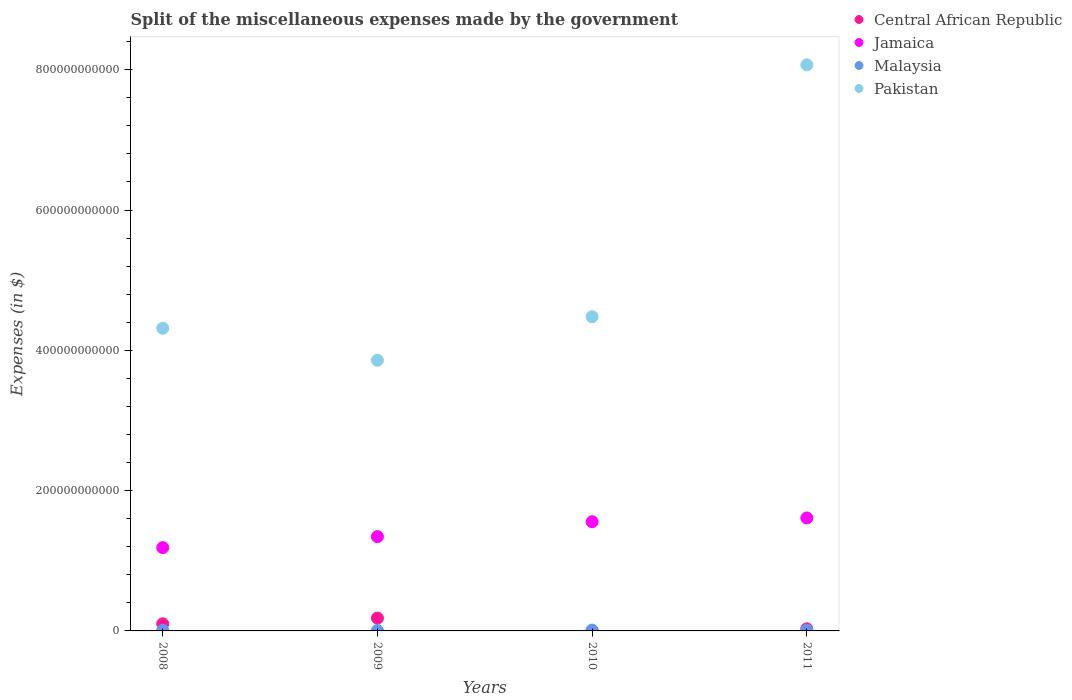What is the miscellaneous expenses made by the government in Pakistan in 2011?
Give a very brief answer. 8.07e+11. Across all years, what is the maximum miscellaneous expenses made by the government in Jamaica?
Provide a succinct answer. 1.61e+11. Across all years, what is the minimum miscellaneous expenses made by the government in Pakistan?
Keep it short and to the point. 3.86e+11. In which year was the miscellaneous expenses made by the government in Malaysia maximum?
Make the answer very short. 2010. What is the total miscellaneous expenses made by the government in Malaysia in the graph?
Provide a succinct answer. 3.83e+09. What is the difference between the miscellaneous expenses made by the government in Malaysia in 2008 and that in 2011?
Ensure brevity in your answer.  -2.89e+08. What is the difference between the miscellaneous expenses made by the government in Pakistan in 2011 and the miscellaneous expenses made by the government in Central African Republic in 2009?
Your response must be concise. 7.89e+11. What is the average miscellaneous expenses made by the government in Central African Republic per year?
Make the answer very short. 7.96e+09. In the year 2011, what is the difference between the miscellaneous expenses made by the government in Central African Republic and miscellaneous expenses made by the government in Jamaica?
Ensure brevity in your answer.  -1.58e+11. In how many years, is the miscellaneous expenses made by the government in Pakistan greater than 760000000000 $?
Provide a succinct answer. 1. What is the ratio of the miscellaneous expenses made by the government in Jamaica in 2008 to that in 2011?
Your answer should be compact. 0.74. Is the miscellaneous expenses made by the government in Jamaica in 2010 less than that in 2011?
Ensure brevity in your answer.  Yes. Is the difference between the miscellaneous expenses made by the government in Central African Republic in 2008 and 2011 greater than the difference between the miscellaneous expenses made by the government in Jamaica in 2008 and 2011?
Offer a terse response. Yes. What is the difference between the highest and the second highest miscellaneous expenses made by the government in Jamaica?
Your answer should be very brief. 5.40e+09. What is the difference between the highest and the lowest miscellaneous expenses made by the government in Malaysia?
Provide a succinct answer. 4.70e+08. Is the sum of the miscellaneous expenses made by the government in Malaysia in 2008 and 2011 greater than the maximum miscellaneous expenses made by the government in Central African Republic across all years?
Your answer should be compact. No. Is it the case that in every year, the sum of the miscellaneous expenses made by the government in Jamaica and miscellaneous expenses made by the government in Pakistan  is greater than the miscellaneous expenses made by the government in Malaysia?
Provide a succinct answer. Yes. Is the miscellaneous expenses made by the government in Central African Republic strictly less than the miscellaneous expenses made by the government in Pakistan over the years?
Offer a very short reply. Yes. How many dotlines are there?
Keep it short and to the point. 4. How many years are there in the graph?
Provide a short and direct response. 4. What is the difference between two consecutive major ticks on the Y-axis?
Your response must be concise. 2.00e+11. Does the graph contain any zero values?
Your answer should be compact. No. Does the graph contain grids?
Give a very brief answer. No. Where does the legend appear in the graph?
Offer a very short reply. Top right. What is the title of the graph?
Provide a short and direct response. Split of the miscellaneous expenses made by the government. What is the label or title of the X-axis?
Keep it short and to the point. Years. What is the label or title of the Y-axis?
Give a very brief answer. Expenses (in $). What is the Expenses (in $) of Central African Republic in 2008?
Provide a short and direct response. 1.01e+1. What is the Expenses (in $) in Jamaica in 2008?
Make the answer very short. 1.19e+11. What is the Expenses (in $) in Malaysia in 2008?
Offer a very short reply. 8.49e+08. What is the Expenses (in $) in Pakistan in 2008?
Offer a terse response. 4.31e+11. What is the Expenses (in $) of Central African Republic in 2009?
Your answer should be very brief. 1.83e+1. What is the Expenses (in $) in Jamaica in 2009?
Your answer should be very brief. 1.34e+11. What is the Expenses (in $) in Malaysia in 2009?
Your response must be concise. 6.85e+08. What is the Expenses (in $) in Pakistan in 2009?
Your answer should be compact. 3.86e+11. What is the Expenses (in $) in Central African Republic in 2010?
Provide a short and direct response. 4.00e+08. What is the Expenses (in $) of Jamaica in 2010?
Offer a very short reply. 1.56e+11. What is the Expenses (in $) in Malaysia in 2010?
Offer a terse response. 1.15e+09. What is the Expenses (in $) in Pakistan in 2010?
Provide a short and direct response. 4.48e+11. What is the Expenses (in $) in Central African Republic in 2011?
Your answer should be compact. 3.00e+09. What is the Expenses (in $) in Jamaica in 2011?
Your answer should be very brief. 1.61e+11. What is the Expenses (in $) in Malaysia in 2011?
Your response must be concise. 1.14e+09. What is the Expenses (in $) of Pakistan in 2011?
Your answer should be very brief. 8.07e+11. Across all years, what is the maximum Expenses (in $) in Central African Republic?
Your answer should be very brief. 1.83e+1. Across all years, what is the maximum Expenses (in $) of Jamaica?
Provide a short and direct response. 1.61e+11. Across all years, what is the maximum Expenses (in $) of Malaysia?
Provide a short and direct response. 1.15e+09. Across all years, what is the maximum Expenses (in $) of Pakistan?
Provide a short and direct response. 8.07e+11. Across all years, what is the minimum Expenses (in $) of Central African Republic?
Provide a succinct answer. 4.00e+08. Across all years, what is the minimum Expenses (in $) in Jamaica?
Your answer should be very brief. 1.19e+11. Across all years, what is the minimum Expenses (in $) of Malaysia?
Your answer should be compact. 6.85e+08. Across all years, what is the minimum Expenses (in $) of Pakistan?
Give a very brief answer. 3.86e+11. What is the total Expenses (in $) of Central African Republic in the graph?
Your response must be concise. 3.18e+1. What is the total Expenses (in $) in Jamaica in the graph?
Offer a very short reply. 5.70e+11. What is the total Expenses (in $) of Malaysia in the graph?
Offer a terse response. 3.83e+09. What is the total Expenses (in $) of Pakistan in the graph?
Ensure brevity in your answer.  2.07e+12. What is the difference between the Expenses (in $) of Central African Republic in 2008 and that in 2009?
Give a very brief answer. -8.19e+09. What is the difference between the Expenses (in $) in Jamaica in 2008 and that in 2009?
Make the answer very short. -1.57e+1. What is the difference between the Expenses (in $) of Malaysia in 2008 and that in 2009?
Make the answer very short. 1.64e+08. What is the difference between the Expenses (in $) of Pakistan in 2008 and that in 2009?
Your answer should be compact. 4.56e+1. What is the difference between the Expenses (in $) of Central African Republic in 2008 and that in 2010?
Your answer should be compact. 9.72e+09. What is the difference between the Expenses (in $) of Jamaica in 2008 and that in 2010?
Your answer should be compact. -3.69e+1. What is the difference between the Expenses (in $) in Malaysia in 2008 and that in 2010?
Give a very brief answer. -3.06e+08. What is the difference between the Expenses (in $) in Pakistan in 2008 and that in 2010?
Offer a very short reply. -1.65e+1. What is the difference between the Expenses (in $) in Central African Republic in 2008 and that in 2011?
Your answer should be compact. 7.12e+09. What is the difference between the Expenses (in $) of Jamaica in 2008 and that in 2011?
Provide a succinct answer. -4.23e+1. What is the difference between the Expenses (in $) of Malaysia in 2008 and that in 2011?
Your response must be concise. -2.89e+08. What is the difference between the Expenses (in $) of Pakistan in 2008 and that in 2011?
Your answer should be very brief. -3.76e+11. What is the difference between the Expenses (in $) of Central African Republic in 2009 and that in 2010?
Your answer should be compact. 1.79e+1. What is the difference between the Expenses (in $) in Jamaica in 2009 and that in 2010?
Your response must be concise. -2.12e+1. What is the difference between the Expenses (in $) in Malaysia in 2009 and that in 2010?
Ensure brevity in your answer.  -4.70e+08. What is the difference between the Expenses (in $) in Pakistan in 2009 and that in 2010?
Provide a short and direct response. -6.21e+1. What is the difference between the Expenses (in $) in Central African Republic in 2009 and that in 2011?
Provide a succinct answer. 1.53e+1. What is the difference between the Expenses (in $) in Jamaica in 2009 and that in 2011?
Provide a short and direct response. -2.66e+1. What is the difference between the Expenses (in $) in Malaysia in 2009 and that in 2011?
Give a very brief answer. -4.53e+08. What is the difference between the Expenses (in $) in Pakistan in 2009 and that in 2011?
Your answer should be very brief. -4.21e+11. What is the difference between the Expenses (in $) of Central African Republic in 2010 and that in 2011?
Offer a terse response. -2.60e+09. What is the difference between the Expenses (in $) in Jamaica in 2010 and that in 2011?
Give a very brief answer. -5.40e+09. What is the difference between the Expenses (in $) of Malaysia in 2010 and that in 2011?
Offer a terse response. 1.68e+07. What is the difference between the Expenses (in $) in Pakistan in 2010 and that in 2011?
Ensure brevity in your answer.  -3.59e+11. What is the difference between the Expenses (in $) in Central African Republic in 2008 and the Expenses (in $) in Jamaica in 2009?
Make the answer very short. -1.24e+11. What is the difference between the Expenses (in $) in Central African Republic in 2008 and the Expenses (in $) in Malaysia in 2009?
Your answer should be compact. 9.44e+09. What is the difference between the Expenses (in $) of Central African Republic in 2008 and the Expenses (in $) of Pakistan in 2009?
Your answer should be very brief. -3.76e+11. What is the difference between the Expenses (in $) of Jamaica in 2008 and the Expenses (in $) of Malaysia in 2009?
Offer a terse response. 1.18e+11. What is the difference between the Expenses (in $) of Jamaica in 2008 and the Expenses (in $) of Pakistan in 2009?
Provide a short and direct response. -2.67e+11. What is the difference between the Expenses (in $) in Malaysia in 2008 and the Expenses (in $) in Pakistan in 2009?
Your response must be concise. -3.85e+11. What is the difference between the Expenses (in $) in Central African Republic in 2008 and the Expenses (in $) in Jamaica in 2010?
Provide a short and direct response. -1.46e+11. What is the difference between the Expenses (in $) of Central African Republic in 2008 and the Expenses (in $) of Malaysia in 2010?
Ensure brevity in your answer.  8.97e+09. What is the difference between the Expenses (in $) of Central African Republic in 2008 and the Expenses (in $) of Pakistan in 2010?
Offer a terse response. -4.38e+11. What is the difference between the Expenses (in $) of Jamaica in 2008 and the Expenses (in $) of Malaysia in 2010?
Provide a short and direct response. 1.18e+11. What is the difference between the Expenses (in $) of Jamaica in 2008 and the Expenses (in $) of Pakistan in 2010?
Offer a very short reply. -3.29e+11. What is the difference between the Expenses (in $) of Malaysia in 2008 and the Expenses (in $) of Pakistan in 2010?
Give a very brief answer. -4.47e+11. What is the difference between the Expenses (in $) of Central African Republic in 2008 and the Expenses (in $) of Jamaica in 2011?
Make the answer very short. -1.51e+11. What is the difference between the Expenses (in $) of Central African Republic in 2008 and the Expenses (in $) of Malaysia in 2011?
Your answer should be very brief. 8.98e+09. What is the difference between the Expenses (in $) in Central African Republic in 2008 and the Expenses (in $) in Pakistan in 2011?
Ensure brevity in your answer.  -7.97e+11. What is the difference between the Expenses (in $) of Jamaica in 2008 and the Expenses (in $) of Malaysia in 2011?
Your answer should be compact. 1.18e+11. What is the difference between the Expenses (in $) in Jamaica in 2008 and the Expenses (in $) in Pakistan in 2011?
Offer a very short reply. -6.88e+11. What is the difference between the Expenses (in $) of Malaysia in 2008 and the Expenses (in $) of Pakistan in 2011?
Your response must be concise. -8.06e+11. What is the difference between the Expenses (in $) of Central African Republic in 2009 and the Expenses (in $) of Jamaica in 2010?
Provide a succinct answer. -1.37e+11. What is the difference between the Expenses (in $) in Central African Republic in 2009 and the Expenses (in $) in Malaysia in 2010?
Offer a very short reply. 1.72e+1. What is the difference between the Expenses (in $) of Central African Republic in 2009 and the Expenses (in $) of Pakistan in 2010?
Your answer should be compact. -4.30e+11. What is the difference between the Expenses (in $) in Jamaica in 2009 and the Expenses (in $) in Malaysia in 2010?
Provide a succinct answer. 1.33e+11. What is the difference between the Expenses (in $) in Jamaica in 2009 and the Expenses (in $) in Pakistan in 2010?
Give a very brief answer. -3.14e+11. What is the difference between the Expenses (in $) of Malaysia in 2009 and the Expenses (in $) of Pakistan in 2010?
Make the answer very short. -4.47e+11. What is the difference between the Expenses (in $) in Central African Republic in 2009 and the Expenses (in $) in Jamaica in 2011?
Offer a terse response. -1.43e+11. What is the difference between the Expenses (in $) in Central African Republic in 2009 and the Expenses (in $) in Malaysia in 2011?
Your answer should be compact. 1.72e+1. What is the difference between the Expenses (in $) of Central African Republic in 2009 and the Expenses (in $) of Pakistan in 2011?
Give a very brief answer. -7.89e+11. What is the difference between the Expenses (in $) of Jamaica in 2009 and the Expenses (in $) of Malaysia in 2011?
Keep it short and to the point. 1.33e+11. What is the difference between the Expenses (in $) in Jamaica in 2009 and the Expenses (in $) in Pakistan in 2011?
Provide a short and direct response. -6.73e+11. What is the difference between the Expenses (in $) of Malaysia in 2009 and the Expenses (in $) of Pakistan in 2011?
Give a very brief answer. -8.06e+11. What is the difference between the Expenses (in $) of Central African Republic in 2010 and the Expenses (in $) of Jamaica in 2011?
Give a very brief answer. -1.61e+11. What is the difference between the Expenses (in $) of Central African Republic in 2010 and the Expenses (in $) of Malaysia in 2011?
Offer a terse response. -7.38e+08. What is the difference between the Expenses (in $) in Central African Republic in 2010 and the Expenses (in $) in Pakistan in 2011?
Your response must be concise. -8.07e+11. What is the difference between the Expenses (in $) in Jamaica in 2010 and the Expenses (in $) in Malaysia in 2011?
Offer a terse response. 1.55e+11. What is the difference between the Expenses (in $) of Jamaica in 2010 and the Expenses (in $) of Pakistan in 2011?
Your answer should be very brief. -6.51e+11. What is the difference between the Expenses (in $) in Malaysia in 2010 and the Expenses (in $) in Pakistan in 2011?
Keep it short and to the point. -8.06e+11. What is the average Expenses (in $) of Central African Republic per year?
Ensure brevity in your answer.  7.96e+09. What is the average Expenses (in $) in Jamaica per year?
Ensure brevity in your answer.  1.42e+11. What is the average Expenses (in $) of Malaysia per year?
Offer a very short reply. 9.57e+08. What is the average Expenses (in $) in Pakistan per year?
Offer a very short reply. 5.18e+11. In the year 2008, what is the difference between the Expenses (in $) of Central African Republic and Expenses (in $) of Jamaica?
Keep it short and to the point. -1.09e+11. In the year 2008, what is the difference between the Expenses (in $) of Central African Republic and Expenses (in $) of Malaysia?
Your answer should be compact. 9.27e+09. In the year 2008, what is the difference between the Expenses (in $) of Central African Republic and Expenses (in $) of Pakistan?
Give a very brief answer. -4.21e+11. In the year 2008, what is the difference between the Expenses (in $) in Jamaica and Expenses (in $) in Malaysia?
Make the answer very short. 1.18e+11. In the year 2008, what is the difference between the Expenses (in $) of Jamaica and Expenses (in $) of Pakistan?
Provide a short and direct response. -3.13e+11. In the year 2008, what is the difference between the Expenses (in $) in Malaysia and Expenses (in $) in Pakistan?
Your answer should be compact. -4.31e+11. In the year 2009, what is the difference between the Expenses (in $) in Central African Republic and Expenses (in $) in Jamaica?
Your answer should be very brief. -1.16e+11. In the year 2009, what is the difference between the Expenses (in $) in Central African Republic and Expenses (in $) in Malaysia?
Provide a short and direct response. 1.76e+1. In the year 2009, what is the difference between the Expenses (in $) of Central African Republic and Expenses (in $) of Pakistan?
Offer a terse response. -3.68e+11. In the year 2009, what is the difference between the Expenses (in $) of Jamaica and Expenses (in $) of Malaysia?
Provide a short and direct response. 1.34e+11. In the year 2009, what is the difference between the Expenses (in $) in Jamaica and Expenses (in $) in Pakistan?
Ensure brevity in your answer.  -2.51e+11. In the year 2009, what is the difference between the Expenses (in $) of Malaysia and Expenses (in $) of Pakistan?
Make the answer very short. -3.85e+11. In the year 2010, what is the difference between the Expenses (in $) of Central African Republic and Expenses (in $) of Jamaica?
Your answer should be compact. -1.55e+11. In the year 2010, what is the difference between the Expenses (in $) in Central African Republic and Expenses (in $) in Malaysia?
Provide a short and direct response. -7.55e+08. In the year 2010, what is the difference between the Expenses (in $) in Central African Republic and Expenses (in $) in Pakistan?
Ensure brevity in your answer.  -4.48e+11. In the year 2010, what is the difference between the Expenses (in $) in Jamaica and Expenses (in $) in Malaysia?
Your answer should be compact. 1.54e+11. In the year 2010, what is the difference between the Expenses (in $) of Jamaica and Expenses (in $) of Pakistan?
Make the answer very short. -2.92e+11. In the year 2010, what is the difference between the Expenses (in $) in Malaysia and Expenses (in $) in Pakistan?
Provide a short and direct response. -4.47e+11. In the year 2011, what is the difference between the Expenses (in $) of Central African Republic and Expenses (in $) of Jamaica?
Offer a very short reply. -1.58e+11. In the year 2011, what is the difference between the Expenses (in $) of Central African Republic and Expenses (in $) of Malaysia?
Keep it short and to the point. 1.86e+09. In the year 2011, what is the difference between the Expenses (in $) of Central African Republic and Expenses (in $) of Pakistan?
Ensure brevity in your answer.  -8.04e+11. In the year 2011, what is the difference between the Expenses (in $) in Jamaica and Expenses (in $) in Malaysia?
Offer a terse response. 1.60e+11. In the year 2011, what is the difference between the Expenses (in $) in Jamaica and Expenses (in $) in Pakistan?
Offer a terse response. -6.46e+11. In the year 2011, what is the difference between the Expenses (in $) in Malaysia and Expenses (in $) in Pakistan?
Provide a succinct answer. -8.06e+11. What is the ratio of the Expenses (in $) of Central African Republic in 2008 to that in 2009?
Keep it short and to the point. 0.55. What is the ratio of the Expenses (in $) in Jamaica in 2008 to that in 2009?
Ensure brevity in your answer.  0.88. What is the ratio of the Expenses (in $) in Malaysia in 2008 to that in 2009?
Your response must be concise. 1.24. What is the ratio of the Expenses (in $) of Pakistan in 2008 to that in 2009?
Provide a short and direct response. 1.12. What is the ratio of the Expenses (in $) of Central African Republic in 2008 to that in 2010?
Give a very brief answer. 25.3. What is the ratio of the Expenses (in $) in Jamaica in 2008 to that in 2010?
Ensure brevity in your answer.  0.76. What is the ratio of the Expenses (in $) in Malaysia in 2008 to that in 2010?
Provide a succinct answer. 0.74. What is the ratio of the Expenses (in $) in Pakistan in 2008 to that in 2010?
Keep it short and to the point. 0.96. What is the ratio of the Expenses (in $) of Central African Republic in 2008 to that in 2011?
Provide a succinct answer. 3.37. What is the ratio of the Expenses (in $) of Jamaica in 2008 to that in 2011?
Provide a succinct answer. 0.74. What is the ratio of the Expenses (in $) of Malaysia in 2008 to that in 2011?
Ensure brevity in your answer.  0.75. What is the ratio of the Expenses (in $) of Pakistan in 2008 to that in 2011?
Keep it short and to the point. 0.53. What is the ratio of the Expenses (in $) of Central African Republic in 2009 to that in 2010?
Your answer should be compact. 45.77. What is the ratio of the Expenses (in $) in Jamaica in 2009 to that in 2010?
Offer a very short reply. 0.86. What is the ratio of the Expenses (in $) of Malaysia in 2009 to that in 2010?
Give a very brief answer. 0.59. What is the ratio of the Expenses (in $) of Pakistan in 2009 to that in 2010?
Provide a succinct answer. 0.86. What is the ratio of the Expenses (in $) of Central African Republic in 2009 to that in 2011?
Provide a succinct answer. 6.1. What is the ratio of the Expenses (in $) of Jamaica in 2009 to that in 2011?
Provide a succinct answer. 0.83. What is the ratio of the Expenses (in $) in Malaysia in 2009 to that in 2011?
Keep it short and to the point. 0.6. What is the ratio of the Expenses (in $) in Pakistan in 2009 to that in 2011?
Provide a succinct answer. 0.48. What is the ratio of the Expenses (in $) of Central African Republic in 2010 to that in 2011?
Your answer should be very brief. 0.13. What is the ratio of the Expenses (in $) of Jamaica in 2010 to that in 2011?
Offer a very short reply. 0.97. What is the ratio of the Expenses (in $) in Malaysia in 2010 to that in 2011?
Offer a very short reply. 1.01. What is the ratio of the Expenses (in $) in Pakistan in 2010 to that in 2011?
Keep it short and to the point. 0.56. What is the difference between the highest and the second highest Expenses (in $) in Central African Republic?
Make the answer very short. 8.19e+09. What is the difference between the highest and the second highest Expenses (in $) in Jamaica?
Your answer should be compact. 5.40e+09. What is the difference between the highest and the second highest Expenses (in $) in Malaysia?
Offer a very short reply. 1.68e+07. What is the difference between the highest and the second highest Expenses (in $) of Pakistan?
Your answer should be compact. 3.59e+11. What is the difference between the highest and the lowest Expenses (in $) of Central African Republic?
Your answer should be very brief. 1.79e+1. What is the difference between the highest and the lowest Expenses (in $) of Jamaica?
Your response must be concise. 4.23e+1. What is the difference between the highest and the lowest Expenses (in $) in Malaysia?
Your answer should be very brief. 4.70e+08. What is the difference between the highest and the lowest Expenses (in $) in Pakistan?
Offer a terse response. 4.21e+11. 